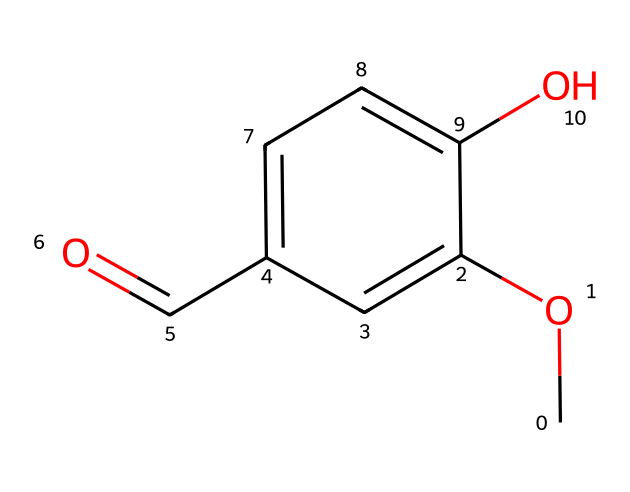What is the functional group present in this molecule? The molecule features a hydroxyl group (-OH) attached to an aromatic ring, which is characteristic of phenols. The presence of this group makes it a phenolic compound.
Answer: hydroxyl group How many carbon atoms are there in vanillin? By examining the structure, we can count a total of eight carbon atoms present in the SMILES representation (including the aromatic ring and the carbonyl group).
Answer: eight What type of compound is vanillin? Vanillin belongs to the class of organic compounds called phenols due to the presence of a hydroxyl group on an aromatic ring. This classification is supported by the overall structure and functional groups present.
Answer: phenol What is the position of the methoxy group (-OCH3) in relation to the hydroxyl group (-OH)? The methoxy group is located at the para position compared to the hydroxyl group on the aromatic ring. This can be determined by the numbering of the carbon atoms in the structure.
Answer: para position How many distinct functional groups are present in vanillin? The molecule contains two distinct functional groups: a hydroxyl group (-OH) and an aldehyde group (-CHO). These can be identified from the functional groups seen in the SMILES notation.
Answer: two What kind of reaction might vanillin undergo due to its aldehyde group? The aldehyde group present in vanillin can undergo oxidation reactions, such as converting to a carboxylic acid. This behavior is typical for aldehyde functional groups, and the presence of reactive hydrogen allows for such transformations.
Answer: oxidation 